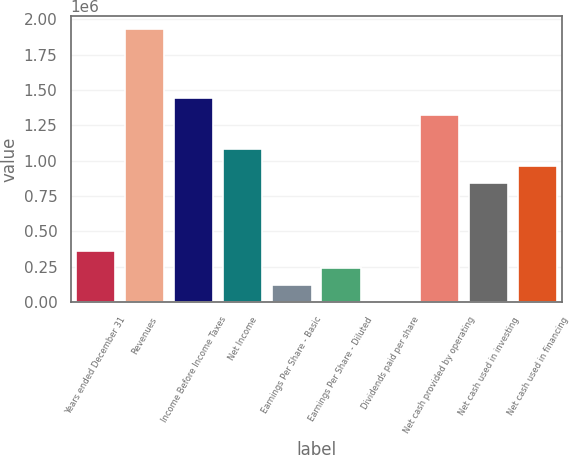Convert chart to OTSL. <chart><loc_0><loc_0><loc_500><loc_500><bar_chart><fcel>Years ended December 31<fcel>Revenues<fcel>Income Before Income Taxes<fcel>Net Income<fcel>Earnings Per Share - Basic<fcel>Earnings Per Share - Diluted<fcel>Dividends paid per share<fcel>Net cash provided by operating<fcel>Net cash used in investing<fcel>Net cash used in financing<nl><fcel>361519<fcel>1.9281e+06<fcel>1.44608e+06<fcel>1.08456e+06<fcel>120507<fcel>241013<fcel>0.28<fcel>1.32557e+06<fcel>843545<fcel>964051<nl></chart> 